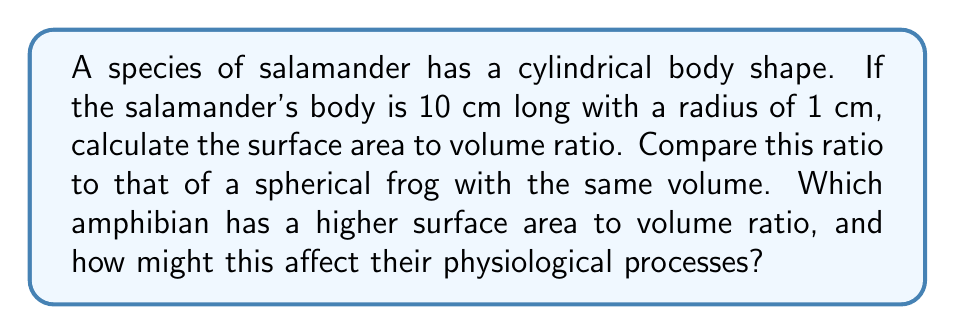Can you answer this question? Let's approach this step-by-step:

1. Calculate the volume and surface area of the cylindrical salamander:

   Volume of cylinder: $V_c = \pi r^2 h$
   $$V_c = \pi \cdot (1 \text{ cm})^2 \cdot 10 \text{ cm} = 10\pi \text{ cm}^3$$

   Surface area of cylinder: $SA_c = 2\pi r h + 2\pi r^2$
   $$SA_c = 2\pi \cdot 1 \text{ cm} \cdot 10 \text{ cm} + 2\pi \cdot (1 \text{ cm})^2 = 22\pi \text{ cm}^2$$

2. Calculate the surface area to volume ratio for the salamander:
   $$\text{SA:V}_c = \frac{SA_c}{V_c} = \frac{22\pi \text{ cm}^2}{10\pi \text{ cm}^3} = 2.2 \text{ cm}^{-1}$$

3. For the spherical frog with the same volume:

   Volume of sphere: $V_s = \frac{4}{3}\pi r^3 = 10\pi \text{ cm}^3$

   Solve for radius:
   $$r = \sqrt[3]{\frac{3V_s}{4\pi}} = \sqrt[3]{\frac{30}{4}} \approx 1.65 \text{ cm}$$

   Surface area of sphere: $SA_s = 4\pi r^2$
   $$SA_s = 4\pi \cdot (1.65 \text{ cm})^2 \approx 34.21 \text{ cm}^2$$

4. Calculate the surface area to volume ratio for the frog:
   $$\text{SA:V}_s = \frac{SA_s}{V_s} = \frac{34.21 \text{ cm}^2}{10\pi \text{ cm}^3} \approx 1.09 \text{ cm}^{-1}$$

The salamander has a higher surface area to volume ratio (2.2 cm^-1 vs 1.09 cm^-1). This higher ratio allows for more efficient gas exchange and heat transfer through the skin, which is crucial for amphibians. However, it also makes the salamander more susceptible to water loss through its skin.
Answer: The salamander's surface area to volume ratio is 2.2 cm^-1, while the spherical frog's ratio is approximately 1.09 cm^-1. The salamander has a higher surface area to volume ratio, which can lead to more efficient gas exchange and heat transfer but also increased risk of desiccation. 